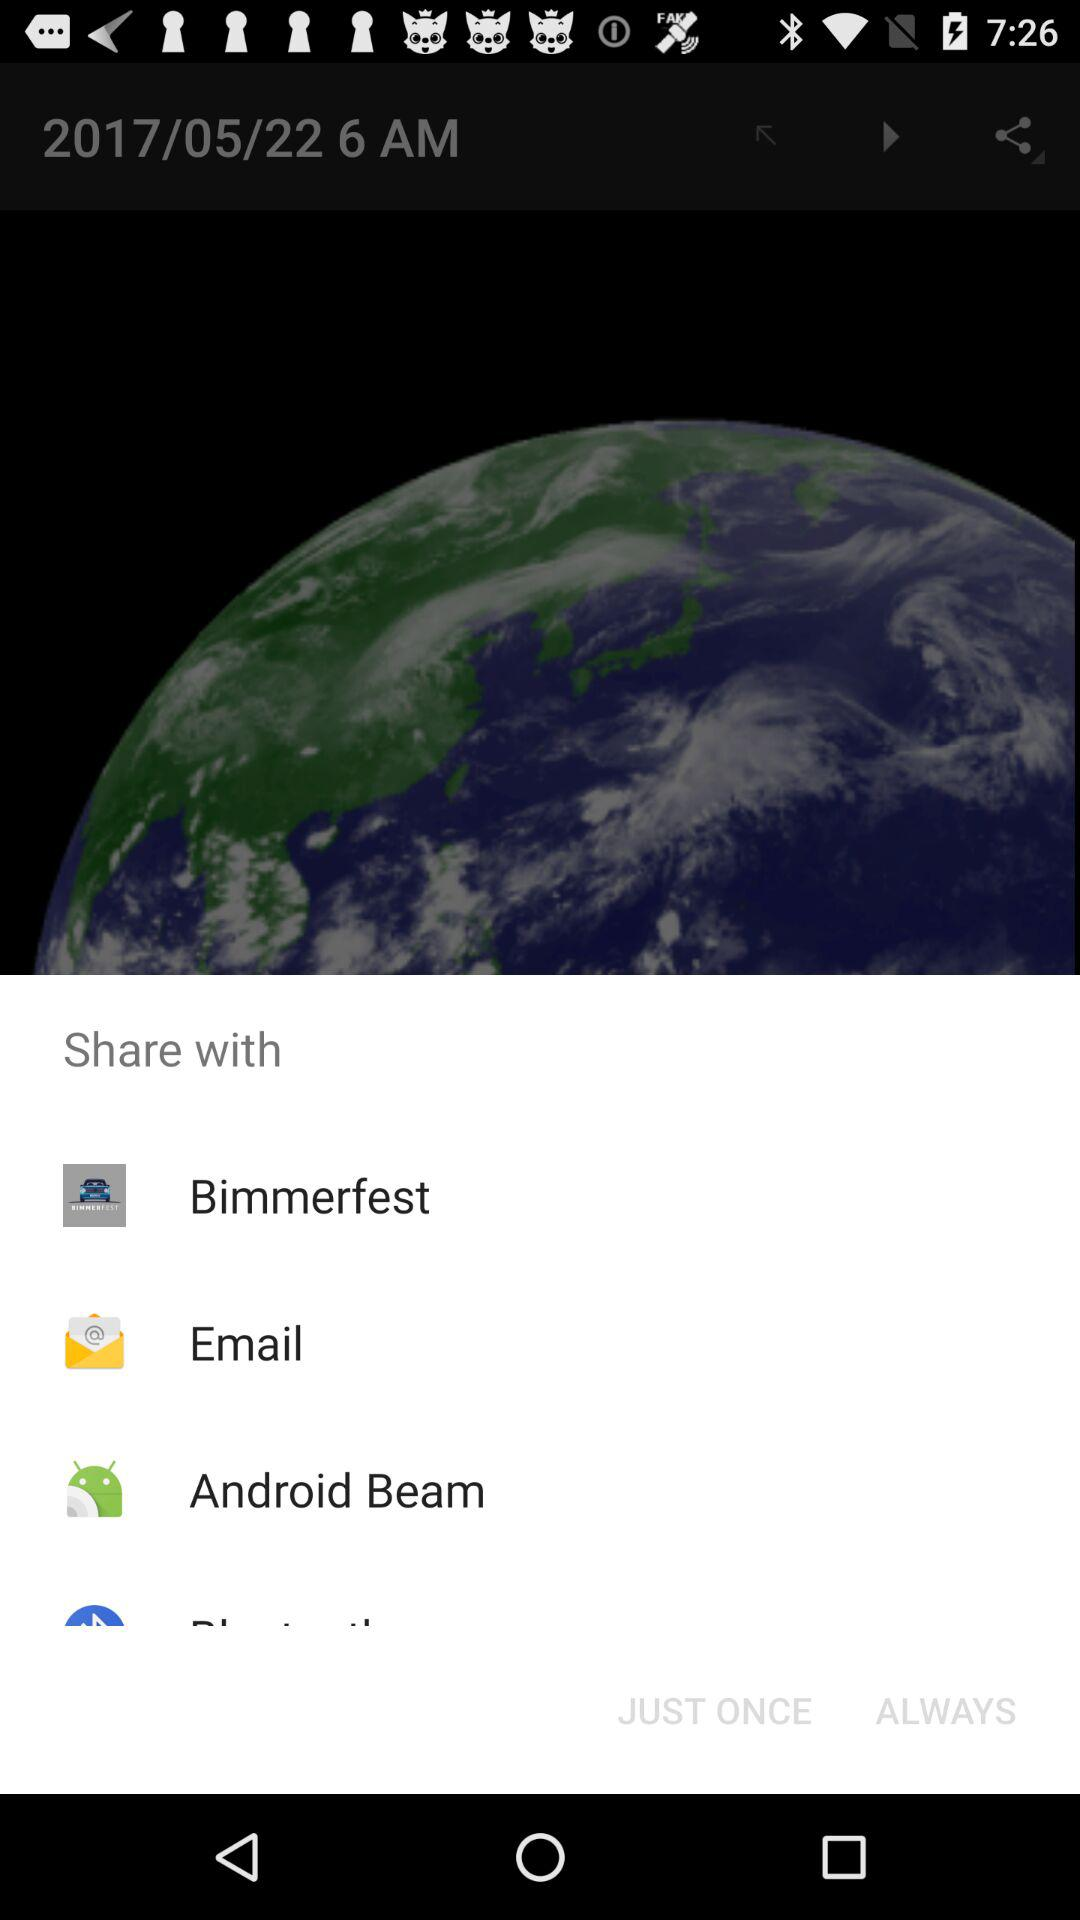How many items are under the Share with header?
Answer the question using a single word or phrase. 4 